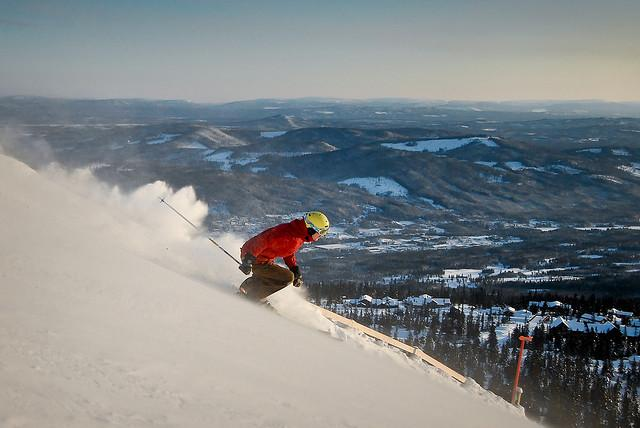What type of region is the man visiting? Please explain your reasoning. mountain. The man is skiing downhill from the top of a snowy hill. 